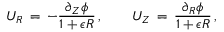Convert formula to latex. <formula><loc_0><loc_0><loc_500><loc_500>U _ { R } \, = \, - \frac { \partial _ { Z } \phi } { 1 + \epsilon R } \, , \quad U _ { Z } \, = \, \frac { \partial _ { R } \phi } { 1 + \epsilon R } \, ,</formula> 